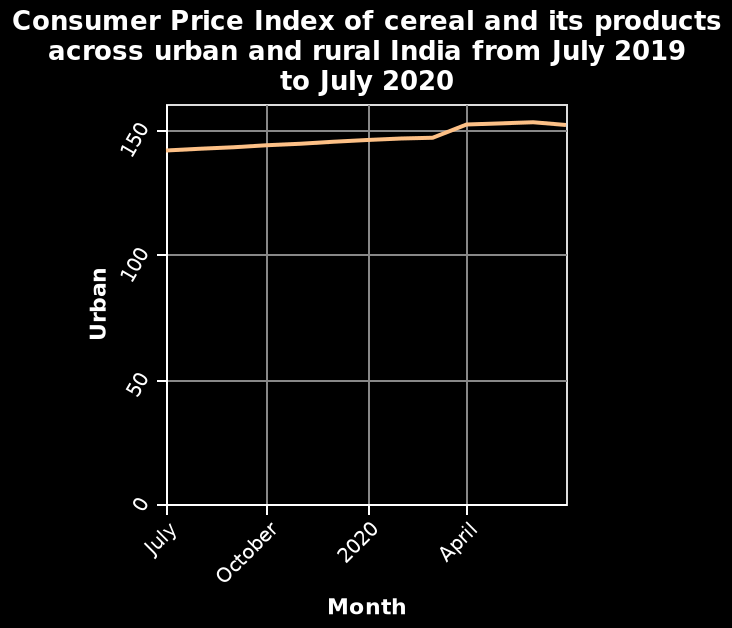<image>
What is the range of values on the y-axis in the line plot? The range of values on the y-axis in the line plot is from 0 to 150. What was the approximate value of Urban in July 2019? The approximate value of Urban in July 2019 was 140. What was the highest value of Urban reached in April? The highest value of Urban reached in April was 155. Offer a thorough analysis of the image. From July 2019 to around March 2020 Urban slowly increases from approximately 140 to just under 150. It then quickly increases to 155 in April and after this point the graph reaches a plateau. 